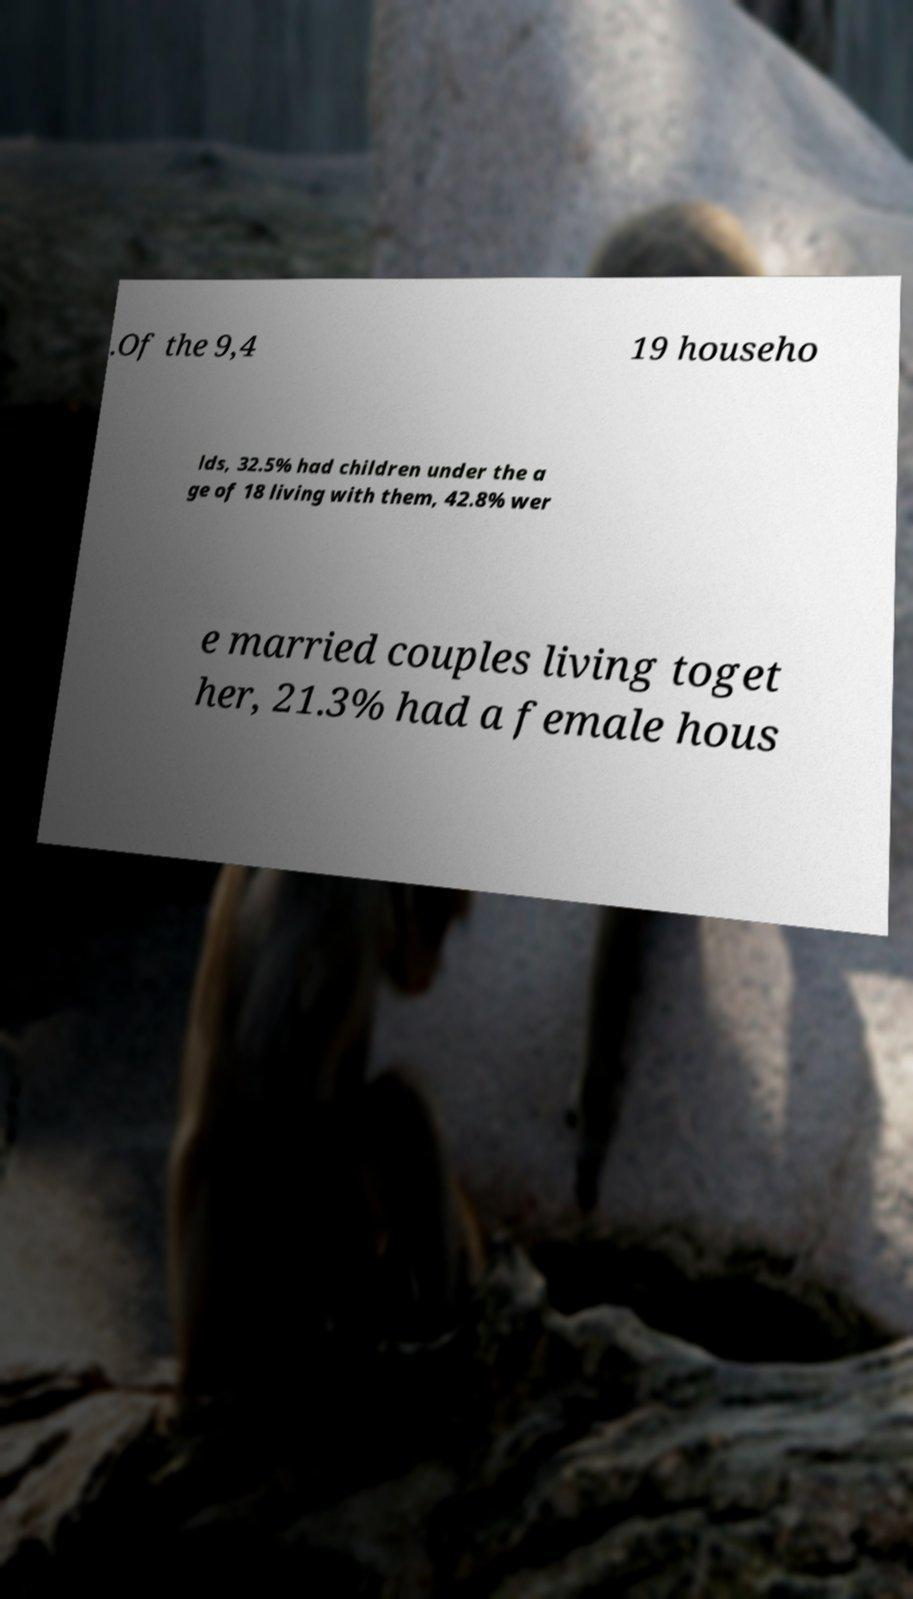Could you extract and type out the text from this image? .Of the 9,4 19 househo lds, 32.5% had children under the a ge of 18 living with them, 42.8% wer e married couples living toget her, 21.3% had a female hous 